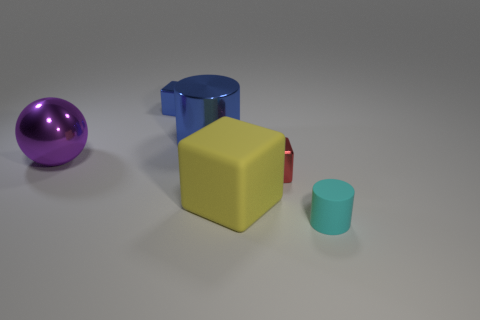What is the shape of the small shiny object that is the same color as the big cylinder?
Keep it short and to the point. Cube. There is a small metal thing that is right of the block behind the large purple metallic thing; is there a small blue object that is behind it?
Offer a terse response. Yes. What number of objects are either yellow rubber things or big metallic things?
Give a very brief answer. 3. Is the tiny cylinder made of the same material as the big thing that is in front of the big purple ball?
Keep it short and to the point. Yes. Is there any other thing of the same color as the shiny cylinder?
Offer a terse response. Yes. What number of objects are things on the right side of the large blue shiny cylinder or big things that are behind the big block?
Ensure brevity in your answer.  5. What shape is the thing that is in front of the large sphere and behind the big yellow thing?
Provide a short and direct response. Cube. How many metal objects are in front of the metallic block left of the yellow block?
Ensure brevity in your answer.  3. Are there any other things that have the same material as the tiny red thing?
Offer a very short reply. Yes. How many objects are either cylinders that are behind the large yellow rubber cube or red metallic objects?
Your answer should be very brief. 2. 